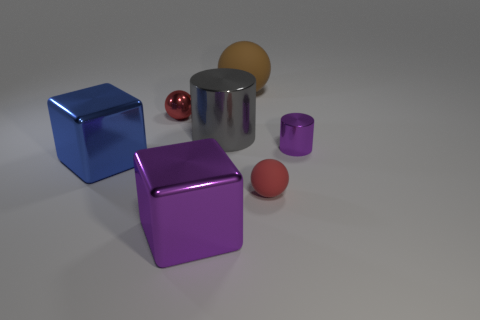Add 1 big blocks. How many objects exist? 8 Subtract all spheres. How many objects are left? 4 Add 4 small red rubber spheres. How many small red rubber spheres are left? 5 Add 5 large blue matte blocks. How many large blue matte blocks exist? 5 Subtract 0 blue cylinders. How many objects are left? 7 Subtract all cyan spheres. Subtract all large rubber objects. How many objects are left? 6 